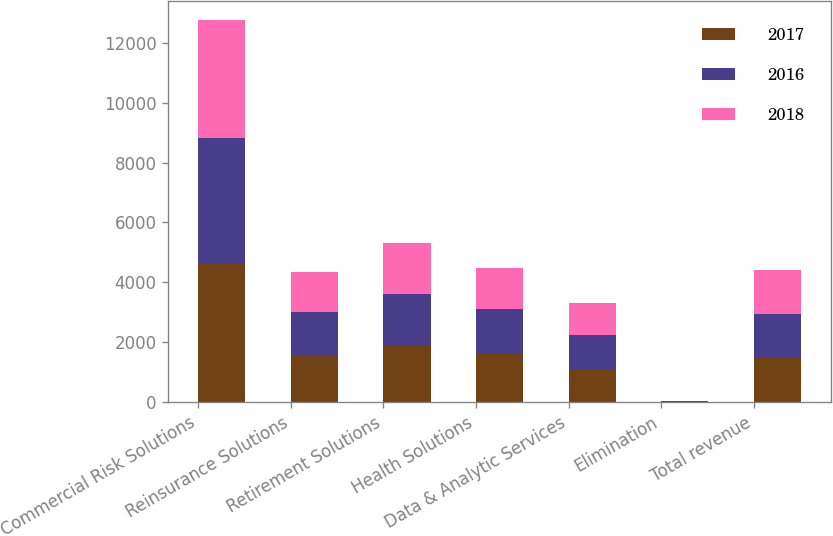Convert chart. <chart><loc_0><loc_0><loc_500><loc_500><stacked_bar_chart><ecel><fcel>Commercial Risk Solutions<fcel>Reinsurance Solutions<fcel>Retirement Solutions<fcel>Health Solutions<fcel>Data & Analytic Services<fcel>Elimination<fcel>Total revenue<nl><fcel>2017<fcel>4652<fcel>1563<fcel>1865<fcel>1596<fcel>1105<fcel>11<fcel>1472<nl><fcel>2016<fcel>4169<fcel>1429<fcel>1755<fcel>1515<fcel>1140<fcel>10<fcel>1472<nl><fcel>2018<fcel>3929<fcel>1361<fcel>1707<fcel>1370<fcel>1050<fcel>8<fcel>1472<nl></chart> 